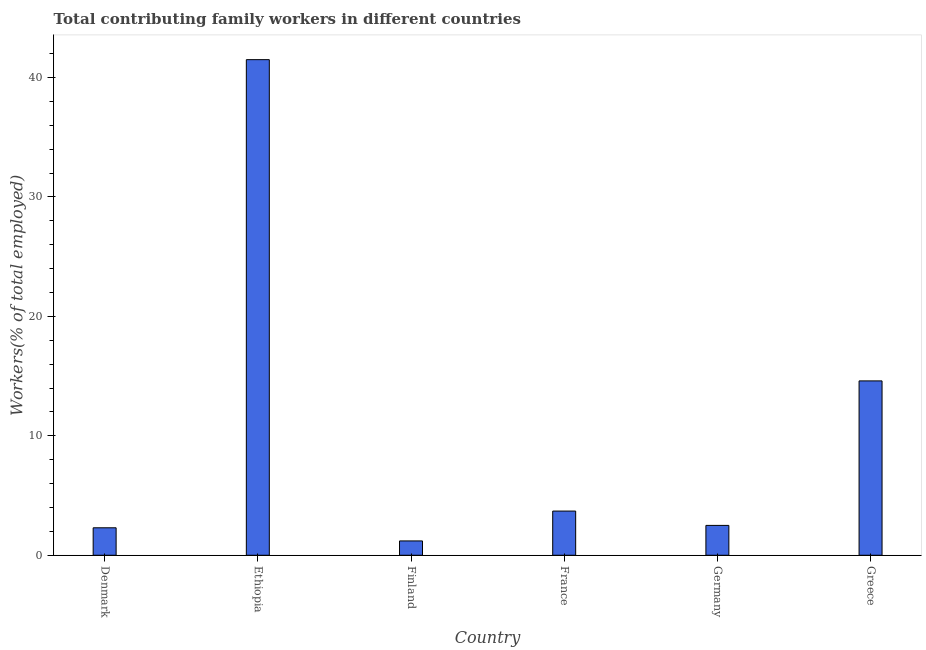Does the graph contain any zero values?
Make the answer very short. No. What is the title of the graph?
Ensure brevity in your answer.  Total contributing family workers in different countries. What is the label or title of the X-axis?
Ensure brevity in your answer.  Country. What is the label or title of the Y-axis?
Provide a succinct answer. Workers(% of total employed). What is the contributing family workers in Finland?
Provide a short and direct response. 1.2. Across all countries, what is the maximum contributing family workers?
Give a very brief answer. 41.5. Across all countries, what is the minimum contributing family workers?
Your answer should be compact. 1.2. In which country was the contributing family workers maximum?
Give a very brief answer. Ethiopia. What is the sum of the contributing family workers?
Offer a very short reply. 65.8. What is the difference between the contributing family workers in Finland and France?
Offer a terse response. -2.5. What is the average contributing family workers per country?
Keep it short and to the point. 10.97. What is the median contributing family workers?
Your response must be concise. 3.1. What is the ratio of the contributing family workers in Denmark to that in France?
Offer a very short reply. 0.62. What is the difference between the highest and the second highest contributing family workers?
Provide a succinct answer. 26.9. What is the difference between the highest and the lowest contributing family workers?
Offer a very short reply. 40.3. In how many countries, is the contributing family workers greater than the average contributing family workers taken over all countries?
Ensure brevity in your answer.  2. How many countries are there in the graph?
Ensure brevity in your answer.  6. What is the difference between two consecutive major ticks on the Y-axis?
Your response must be concise. 10. Are the values on the major ticks of Y-axis written in scientific E-notation?
Provide a succinct answer. No. What is the Workers(% of total employed) of Denmark?
Provide a short and direct response. 2.3. What is the Workers(% of total employed) in Ethiopia?
Give a very brief answer. 41.5. What is the Workers(% of total employed) in Finland?
Your answer should be very brief. 1.2. What is the Workers(% of total employed) in France?
Provide a short and direct response. 3.7. What is the Workers(% of total employed) in Germany?
Offer a very short reply. 2.5. What is the Workers(% of total employed) in Greece?
Your answer should be very brief. 14.6. What is the difference between the Workers(% of total employed) in Denmark and Ethiopia?
Keep it short and to the point. -39.2. What is the difference between the Workers(% of total employed) in Denmark and Finland?
Make the answer very short. 1.1. What is the difference between the Workers(% of total employed) in Denmark and France?
Your answer should be very brief. -1.4. What is the difference between the Workers(% of total employed) in Denmark and Germany?
Offer a terse response. -0.2. What is the difference between the Workers(% of total employed) in Ethiopia and Finland?
Provide a succinct answer. 40.3. What is the difference between the Workers(% of total employed) in Ethiopia and France?
Offer a very short reply. 37.8. What is the difference between the Workers(% of total employed) in Ethiopia and Germany?
Keep it short and to the point. 39. What is the difference between the Workers(% of total employed) in Ethiopia and Greece?
Keep it short and to the point. 26.9. What is the difference between the Workers(% of total employed) in Finland and Germany?
Provide a succinct answer. -1.3. What is the difference between the Workers(% of total employed) in Finland and Greece?
Ensure brevity in your answer.  -13.4. What is the difference between the Workers(% of total employed) in France and Germany?
Ensure brevity in your answer.  1.2. What is the ratio of the Workers(% of total employed) in Denmark to that in Ethiopia?
Your response must be concise. 0.06. What is the ratio of the Workers(% of total employed) in Denmark to that in Finland?
Ensure brevity in your answer.  1.92. What is the ratio of the Workers(% of total employed) in Denmark to that in France?
Your response must be concise. 0.62. What is the ratio of the Workers(% of total employed) in Denmark to that in Germany?
Your answer should be compact. 0.92. What is the ratio of the Workers(% of total employed) in Denmark to that in Greece?
Your response must be concise. 0.16. What is the ratio of the Workers(% of total employed) in Ethiopia to that in Finland?
Keep it short and to the point. 34.58. What is the ratio of the Workers(% of total employed) in Ethiopia to that in France?
Make the answer very short. 11.22. What is the ratio of the Workers(% of total employed) in Ethiopia to that in Greece?
Ensure brevity in your answer.  2.84. What is the ratio of the Workers(% of total employed) in Finland to that in France?
Provide a short and direct response. 0.32. What is the ratio of the Workers(% of total employed) in Finland to that in Germany?
Offer a very short reply. 0.48. What is the ratio of the Workers(% of total employed) in Finland to that in Greece?
Offer a terse response. 0.08. What is the ratio of the Workers(% of total employed) in France to that in Germany?
Give a very brief answer. 1.48. What is the ratio of the Workers(% of total employed) in France to that in Greece?
Offer a terse response. 0.25. What is the ratio of the Workers(% of total employed) in Germany to that in Greece?
Give a very brief answer. 0.17. 